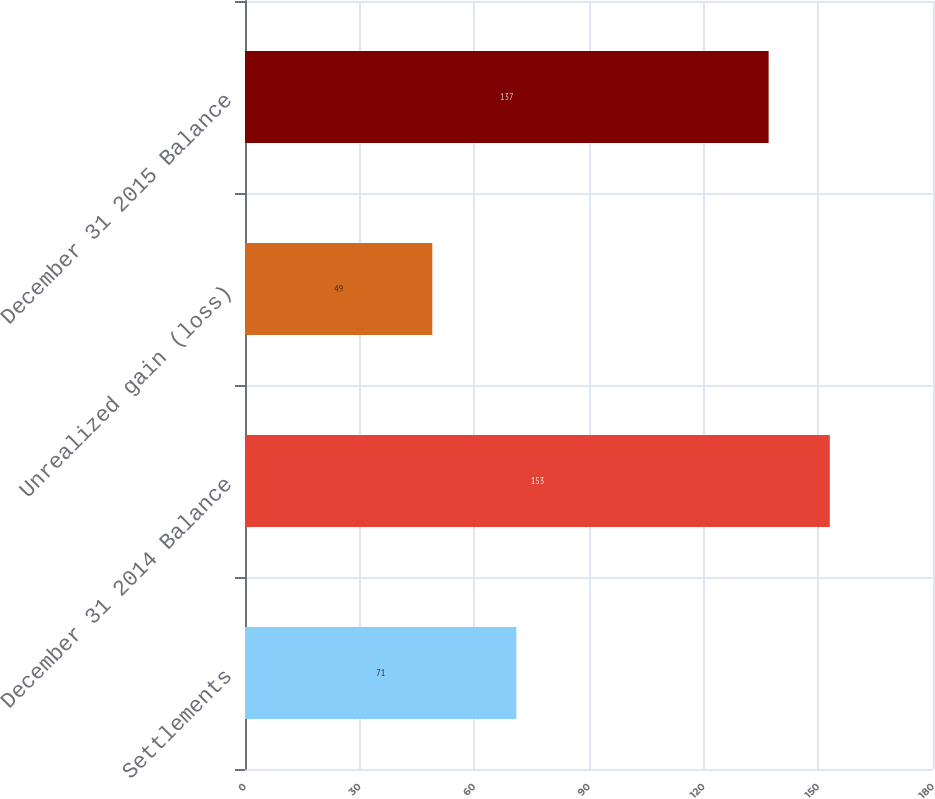Convert chart to OTSL. <chart><loc_0><loc_0><loc_500><loc_500><bar_chart><fcel>Settlements<fcel>December 31 2014 Balance<fcel>Unrealized gain (loss)<fcel>December 31 2015 Balance<nl><fcel>71<fcel>153<fcel>49<fcel>137<nl></chart> 